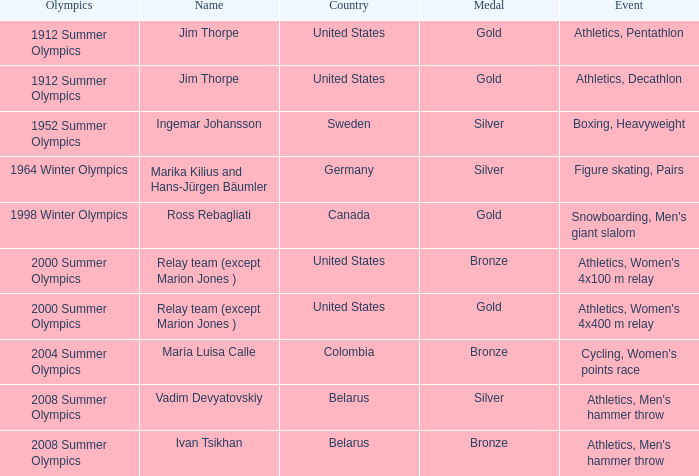Which country in the 2008 summer olympics is vadim devyatovskiy from? Belarus. 